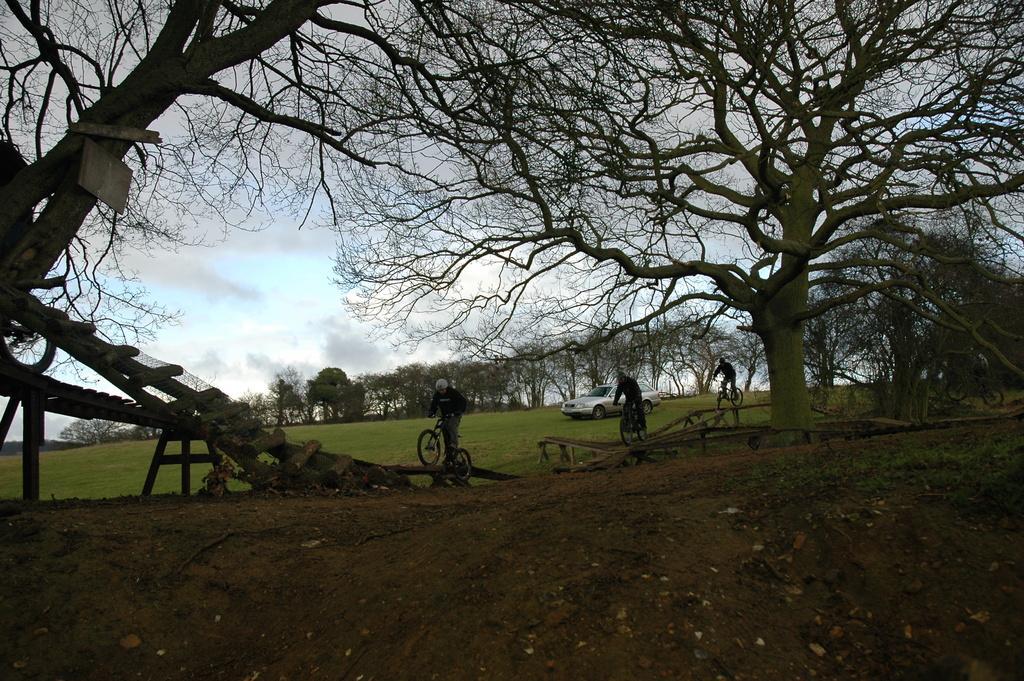Could you give a brief overview of what you see in this image? In this image there are few people riding bicycles beside them there is a car on the grass ground and so many trees around. 